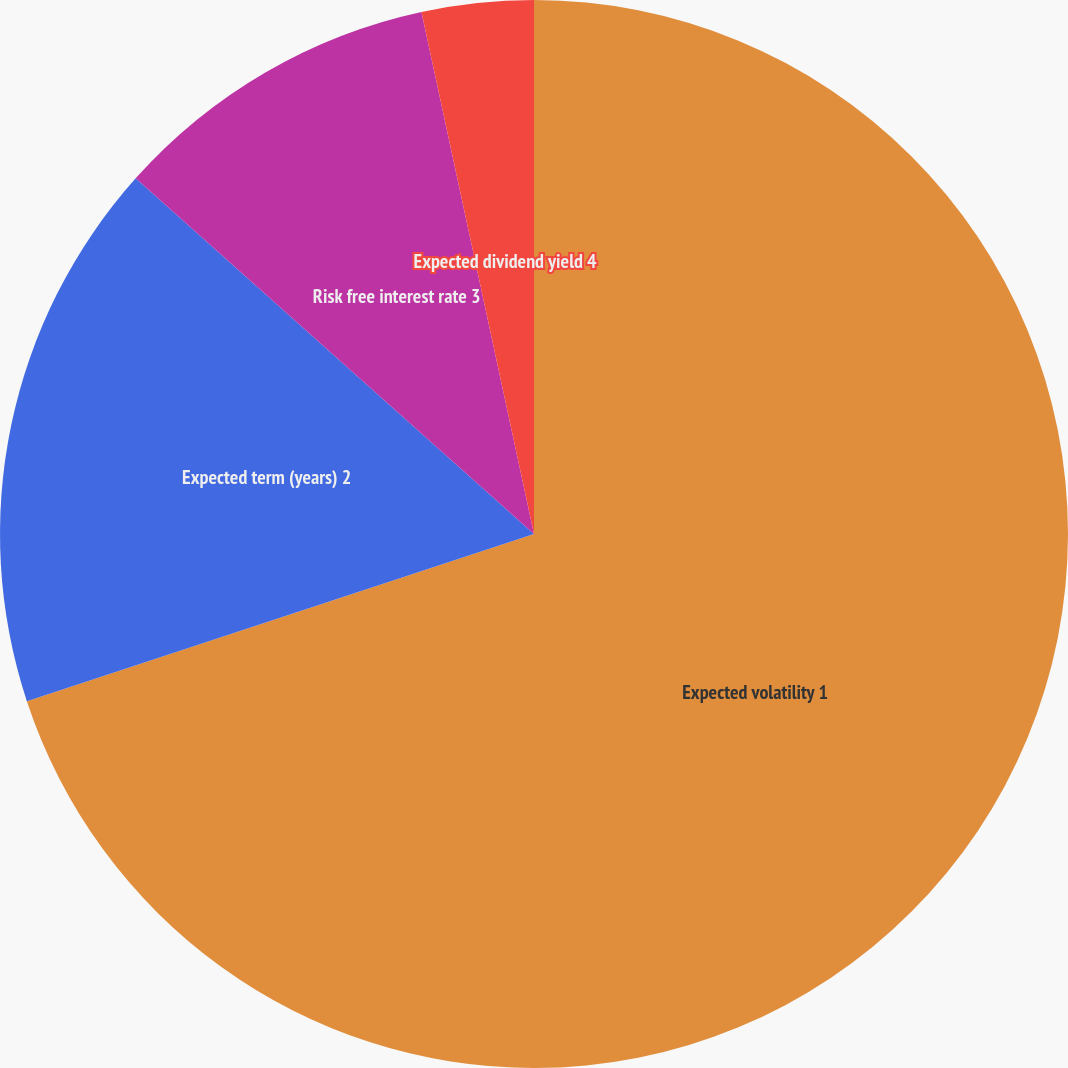<chart> <loc_0><loc_0><loc_500><loc_500><pie_chart><fcel>Expected volatility 1<fcel>Expected term (years) 2<fcel>Risk free interest rate 3<fcel>Expected dividend yield 4<nl><fcel>69.93%<fcel>16.67%<fcel>10.02%<fcel>3.38%<nl></chart> 